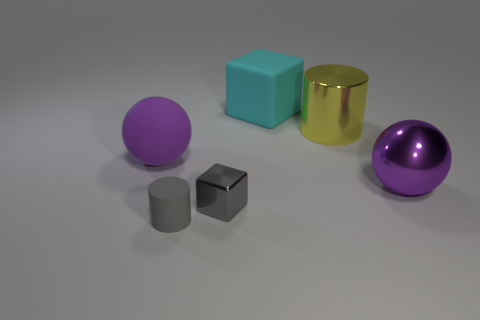Add 4 small cyan matte cylinders. How many objects exist? 10 Subtract all blocks. How many objects are left? 4 Add 3 big cylinders. How many big cylinders are left? 4 Add 2 big gray metal cubes. How many big gray metal cubes exist? 2 Subtract 0 brown balls. How many objects are left? 6 Subtract all gray metallic blocks. Subtract all large yellow things. How many objects are left? 4 